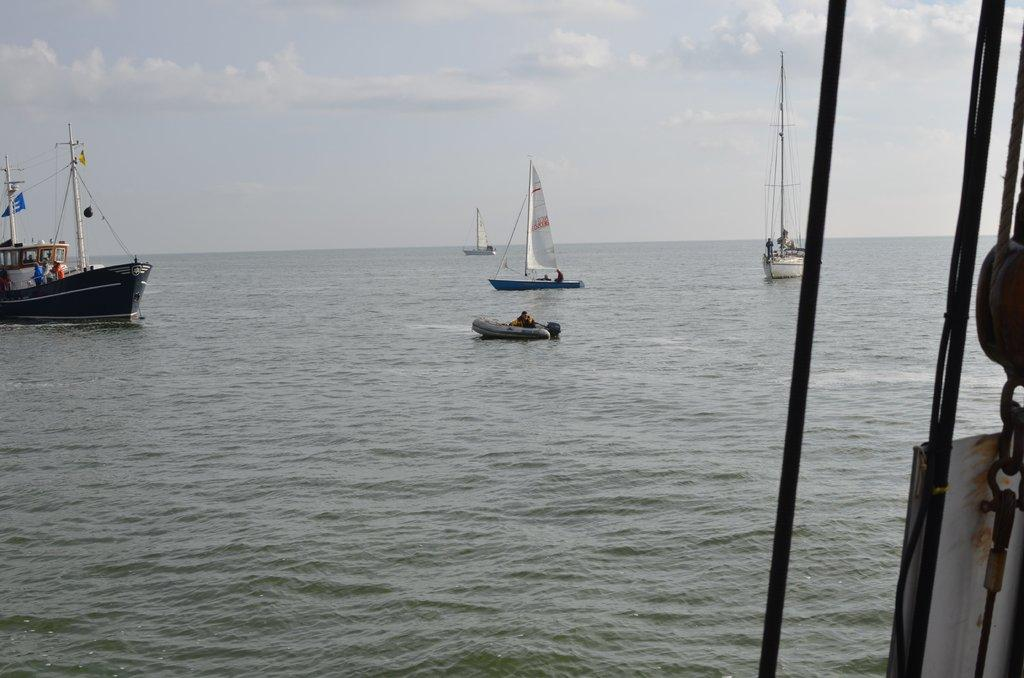What type of vehicles are in the water in the image? There are boats in the water in the image. Are there any people on the boats? Yes, there are people on the boat. What can be seen in the background of the image? The sky is visible in the background of the image. What type of guitar is being played by the person on the boat? There is no guitar present in the image; it only shows boats in the water with people on them. 